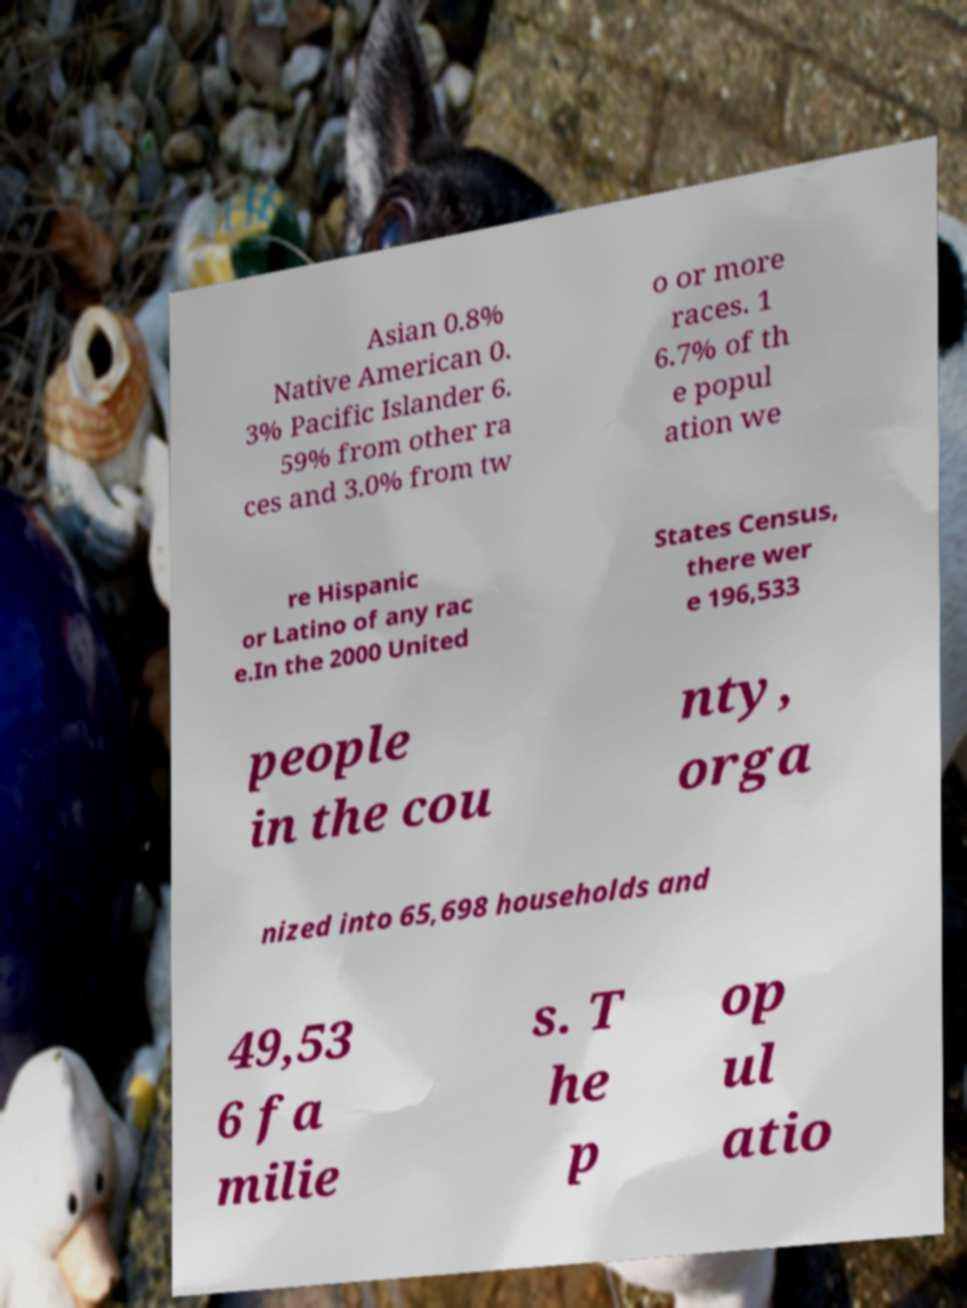Can you accurately transcribe the text from the provided image for me? Asian 0.8% Native American 0. 3% Pacific Islander 6. 59% from other ra ces and 3.0% from tw o or more races. 1 6.7% of th e popul ation we re Hispanic or Latino of any rac e.In the 2000 United States Census, there wer e 196,533 people in the cou nty, orga nized into 65,698 households and 49,53 6 fa milie s. T he p op ul atio 